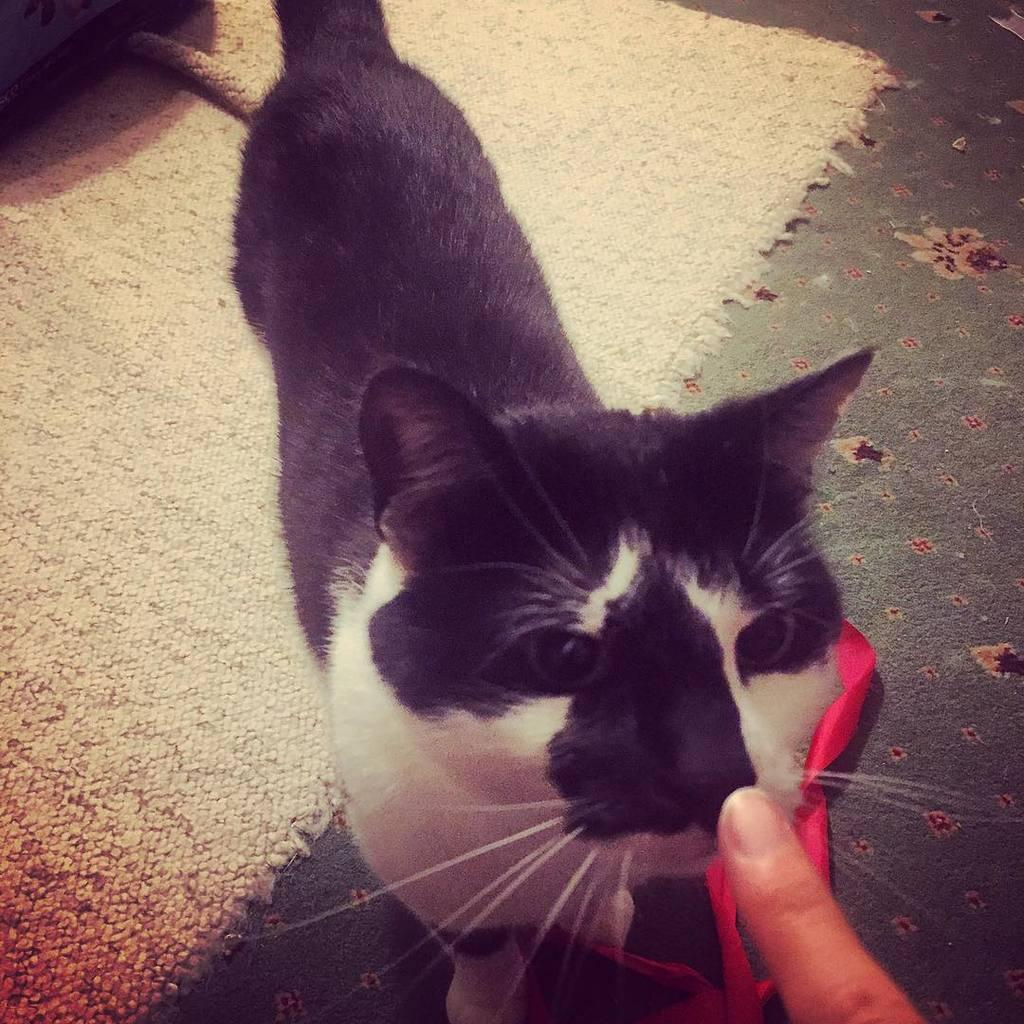What type of animal is in the image? There is a cat in the image. Can you describe the color pattern of the cat? The cat has a white and black color pattern. Where is the cat located in the image? The cat is in the center of the image. What else can be seen at the bottom side of the image? There is a finger at the bottom side of the image. What type of bridge can be seen in the image? There is no bridge present in the image; it features a cat with a white and black color pattern. Which direction is the jar pointing towards in the image? There is no jar present in the image. 